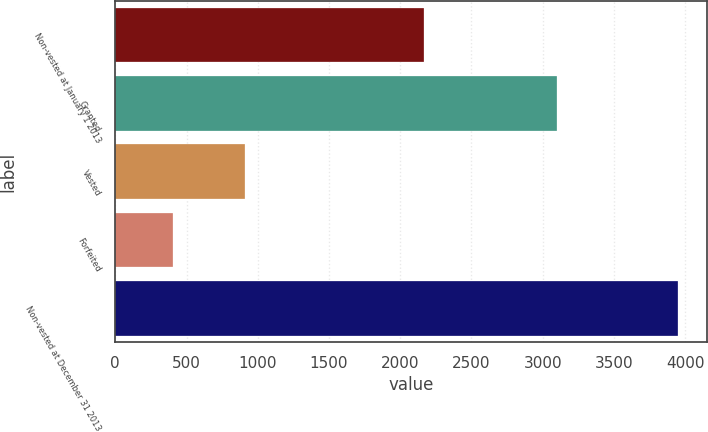<chart> <loc_0><loc_0><loc_500><loc_500><bar_chart><fcel>Non-vested at January 1 2013<fcel>Granted<fcel>Vested<fcel>Forfeited<fcel>Non-vested at December 31 2013<nl><fcel>2164<fcel>3098<fcel>907<fcel>402<fcel>3953<nl></chart> 